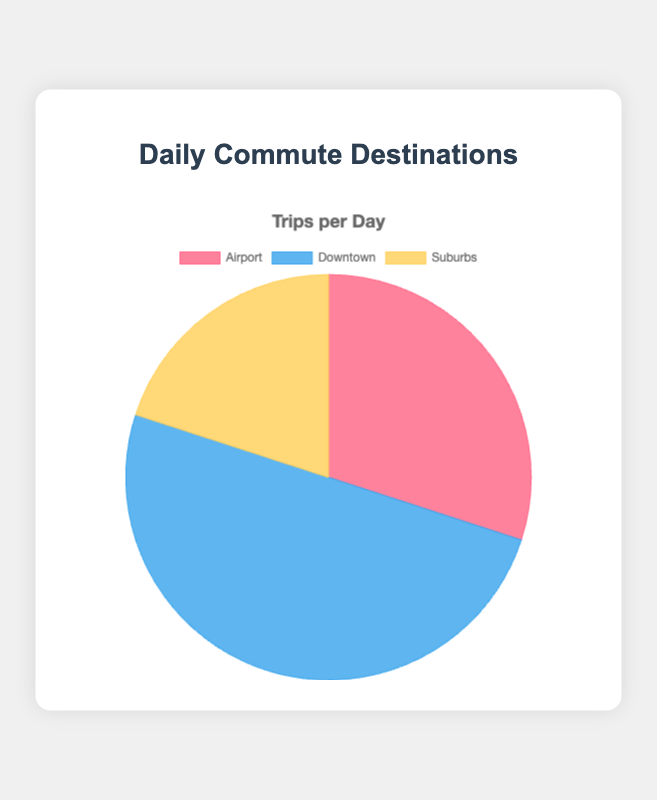What's the destination with the highest number of trips per day? The chart shows three destinations with their respective number of trips per day. Downtown has the highest number of trips, totaling 25.
Answer: Downtown Which destination has fewer trips per day than the Airport? The Airport has 15 trips per day. The Suburbs have fewer trips with 10 per day.
Answer: Suburbs How many more trips per day are there to Downtown compared to the Suburbs? Downtown has 25 trips per day, while the Suburbs have 10. The difference is 25 - 10 = 15 trips per day.
Answer: 15 What fraction of the total trips is made to the Airport? The total number of trips is 15 (Airport) + 25 (Downtown) + 10 (Suburbs) = 50. The fraction of trips to the Airport is 15/50 = 0.3.
Answer: 0.3 What is the average number of trips per day to all destinations? The total number of trips is 50. There are three destinations. The average is 50/3 ≈ 16.67.
Answer: 16.67 Compare the number of trips per day to Downtown and the Suburbs. Downtown has 25 trips per day, while the Suburbs have 10. Downtown has more trips than the Suburbs.
Answer: Downtown has more What is the sum of trips per day to Downtown and the Airport? Downtown has 25 trips per day, and the Airport has 15. Their sum is 25 + 15 = 40 trips per day.
Answer: 40 Which destination is represented by the yellow segment in the chart? The chart visually distinguishes each destination by color. The yellow segment corresponds to the Suburbs.
Answer: Suburbs Estimate the percentage of trips per day to Downtown. The total number of trips is 50. Trips to Downtown are 25. The percentage is (25/50)*100 ≈ 50%.
Answer: 50 